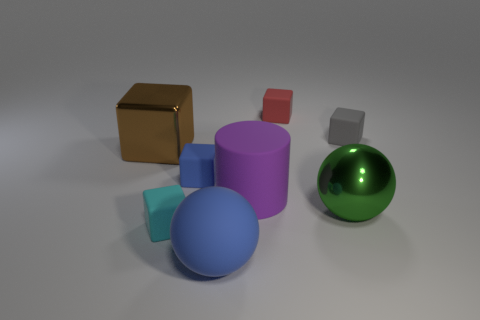Subtract all large metallic cubes. How many cubes are left? 4 Subtract all brown cubes. How many cubes are left? 4 Subtract all cylinders. How many objects are left? 7 Add 2 large purple rubber cylinders. How many objects exist? 10 Subtract all brown cylinders. How many blue spheres are left? 1 Subtract all big purple objects. Subtract all purple cylinders. How many objects are left? 6 Add 8 purple matte cylinders. How many purple matte cylinders are left? 9 Add 6 gray rubber blocks. How many gray rubber blocks exist? 7 Subtract 0 gray cylinders. How many objects are left? 8 Subtract 3 cubes. How many cubes are left? 2 